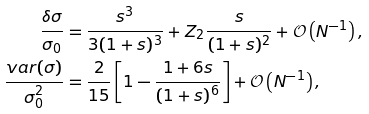Convert formula to latex. <formula><loc_0><loc_0><loc_500><loc_500>\frac { \delta \sigma } { \sigma _ { 0 } } & = \frac { s ^ { 3 } } { 3 ( 1 + s ) ^ { 3 } } + Z _ { 2 } \frac { s } { ( 1 + s ) ^ { 2 } } + \mathcal { O } \left ( N ^ { - 1 } \right ) , \\ \frac { v a r ( \sigma ) } { \sigma _ { 0 } ^ { 2 } } & = \frac { 2 } { 1 5 } \left [ 1 - \frac { 1 + 6 s } { ( 1 + s ) ^ { 6 } } \right ] + \mathcal { O } \left ( N ^ { - 1 } \right ) ,</formula> 